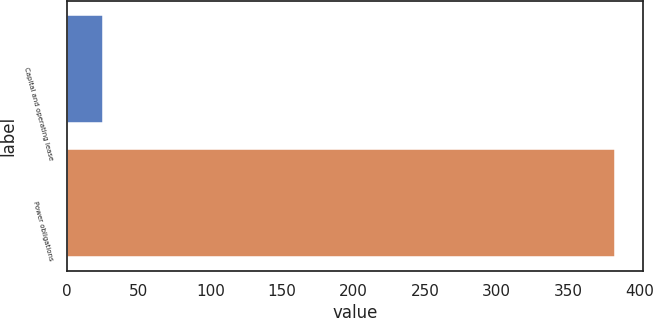Convert chart to OTSL. <chart><loc_0><loc_0><loc_500><loc_500><bar_chart><fcel>Capital and operating lease<fcel>Power obligations<nl><fcel>25<fcel>383<nl></chart> 